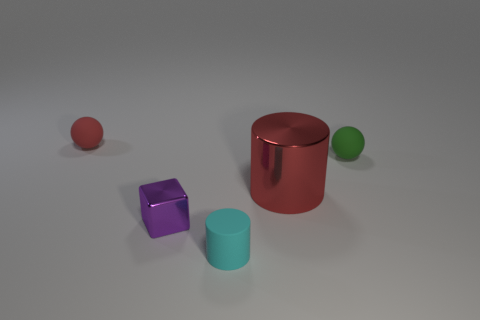Subtract all blocks. How many objects are left? 4 Subtract all blue spheres. Subtract all purple cylinders. How many spheres are left? 2 Subtract all brown cubes. How many red cylinders are left? 1 Subtract all tiny red matte things. Subtract all red objects. How many objects are left? 2 Add 3 big red cylinders. How many big red cylinders are left? 4 Add 3 small cyan cylinders. How many small cyan cylinders exist? 4 Add 3 tiny yellow objects. How many objects exist? 8 Subtract 0 gray spheres. How many objects are left? 5 Subtract 1 spheres. How many spheres are left? 1 